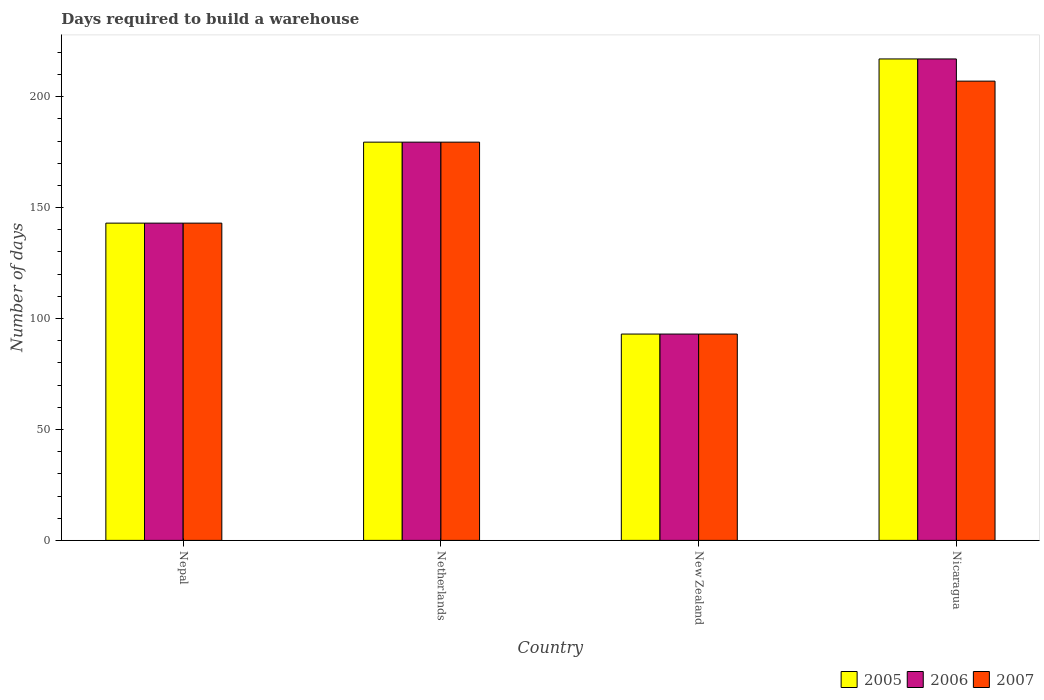Are the number of bars on each tick of the X-axis equal?
Give a very brief answer. Yes. How many bars are there on the 1st tick from the right?
Ensure brevity in your answer.  3. What is the label of the 4th group of bars from the left?
Offer a terse response. Nicaragua. What is the days required to build a warehouse in in 2006 in Netherlands?
Offer a terse response. 179.5. Across all countries, what is the maximum days required to build a warehouse in in 2007?
Offer a very short reply. 207. Across all countries, what is the minimum days required to build a warehouse in in 2005?
Your response must be concise. 93. In which country was the days required to build a warehouse in in 2006 maximum?
Keep it short and to the point. Nicaragua. In which country was the days required to build a warehouse in in 2005 minimum?
Your answer should be very brief. New Zealand. What is the total days required to build a warehouse in in 2007 in the graph?
Ensure brevity in your answer.  622.5. What is the difference between the days required to build a warehouse in in 2005 in Netherlands and that in New Zealand?
Give a very brief answer. 86.5. What is the difference between the days required to build a warehouse in in 2006 in Nicaragua and the days required to build a warehouse in in 2005 in Netherlands?
Your answer should be compact. 37.5. What is the average days required to build a warehouse in in 2007 per country?
Keep it short and to the point. 155.62. What is the ratio of the days required to build a warehouse in in 2007 in Nepal to that in Netherlands?
Ensure brevity in your answer.  0.8. Is the days required to build a warehouse in in 2006 in Netherlands less than that in Nicaragua?
Make the answer very short. Yes. What is the difference between the highest and the second highest days required to build a warehouse in in 2005?
Offer a very short reply. 37.5. What is the difference between the highest and the lowest days required to build a warehouse in in 2005?
Keep it short and to the point. 124. In how many countries, is the days required to build a warehouse in in 2007 greater than the average days required to build a warehouse in in 2007 taken over all countries?
Ensure brevity in your answer.  2. What does the 1st bar from the left in Nepal represents?
Give a very brief answer. 2005. What does the 2nd bar from the right in Nicaragua represents?
Ensure brevity in your answer.  2006. Is it the case that in every country, the sum of the days required to build a warehouse in in 2005 and days required to build a warehouse in in 2007 is greater than the days required to build a warehouse in in 2006?
Keep it short and to the point. Yes. What is the difference between two consecutive major ticks on the Y-axis?
Ensure brevity in your answer.  50. Are the values on the major ticks of Y-axis written in scientific E-notation?
Make the answer very short. No. Does the graph contain any zero values?
Ensure brevity in your answer.  No. How many legend labels are there?
Provide a short and direct response. 3. What is the title of the graph?
Give a very brief answer. Days required to build a warehouse. Does "1997" appear as one of the legend labels in the graph?
Your answer should be compact. No. What is the label or title of the Y-axis?
Your answer should be very brief. Number of days. What is the Number of days of 2005 in Nepal?
Offer a terse response. 143. What is the Number of days in 2006 in Nepal?
Provide a short and direct response. 143. What is the Number of days of 2007 in Nepal?
Ensure brevity in your answer.  143. What is the Number of days of 2005 in Netherlands?
Your answer should be very brief. 179.5. What is the Number of days in 2006 in Netherlands?
Your answer should be compact. 179.5. What is the Number of days in 2007 in Netherlands?
Offer a very short reply. 179.5. What is the Number of days in 2005 in New Zealand?
Keep it short and to the point. 93. What is the Number of days in 2006 in New Zealand?
Provide a short and direct response. 93. What is the Number of days of 2007 in New Zealand?
Offer a very short reply. 93. What is the Number of days in 2005 in Nicaragua?
Provide a succinct answer. 217. What is the Number of days of 2006 in Nicaragua?
Offer a terse response. 217. What is the Number of days of 2007 in Nicaragua?
Your answer should be compact. 207. Across all countries, what is the maximum Number of days of 2005?
Give a very brief answer. 217. Across all countries, what is the maximum Number of days of 2006?
Provide a short and direct response. 217. Across all countries, what is the maximum Number of days in 2007?
Provide a short and direct response. 207. Across all countries, what is the minimum Number of days of 2005?
Make the answer very short. 93. Across all countries, what is the minimum Number of days of 2006?
Offer a very short reply. 93. Across all countries, what is the minimum Number of days of 2007?
Give a very brief answer. 93. What is the total Number of days of 2005 in the graph?
Keep it short and to the point. 632.5. What is the total Number of days in 2006 in the graph?
Your answer should be compact. 632.5. What is the total Number of days in 2007 in the graph?
Offer a very short reply. 622.5. What is the difference between the Number of days of 2005 in Nepal and that in Netherlands?
Provide a short and direct response. -36.5. What is the difference between the Number of days in 2006 in Nepal and that in Netherlands?
Your response must be concise. -36.5. What is the difference between the Number of days in 2007 in Nepal and that in Netherlands?
Your answer should be very brief. -36.5. What is the difference between the Number of days in 2005 in Nepal and that in New Zealand?
Provide a succinct answer. 50. What is the difference between the Number of days in 2005 in Nepal and that in Nicaragua?
Keep it short and to the point. -74. What is the difference between the Number of days of 2006 in Nepal and that in Nicaragua?
Keep it short and to the point. -74. What is the difference between the Number of days in 2007 in Nepal and that in Nicaragua?
Your response must be concise. -64. What is the difference between the Number of days in 2005 in Netherlands and that in New Zealand?
Keep it short and to the point. 86.5. What is the difference between the Number of days of 2006 in Netherlands and that in New Zealand?
Your response must be concise. 86.5. What is the difference between the Number of days in 2007 in Netherlands and that in New Zealand?
Provide a short and direct response. 86.5. What is the difference between the Number of days of 2005 in Netherlands and that in Nicaragua?
Offer a terse response. -37.5. What is the difference between the Number of days in 2006 in Netherlands and that in Nicaragua?
Keep it short and to the point. -37.5. What is the difference between the Number of days in 2007 in Netherlands and that in Nicaragua?
Make the answer very short. -27.5. What is the difference between the Number of days in 2005 in New Zealand and that in Nicaragua?
Your response must be concise. -124. What is the difference between the Number of days in 2006 in New Zealand and that in Nicaragua?
Your response must be concise. -124. What is the difference between the Number of days in 2007 in New Zealand and that in Nicaragua?
Keep it short and to the point. -114. What is the difference between the Number of days of 2005 in Nepal and the Number of days of 2006 in Netherlands?
Make the answer very short. -36.5. What is the difference between the Number of days in 2005 in Nepal and the Number of days in 2007 in Netherlands?
Keep it short and to the point. -36.5. What is the difference between the Number of days in 2006 in Nepal and the Number of days in 2007 in Netherlands?
Provide a short and direct response. -36.5. What is the difference between the Number of days in 2006 in Nepal and the Number of days in 2007 in New Zealand?
Provide a short and direct response. 50. What is the difference between the Number of days in 2005 in Nepal and the Number of days in 2006 in Nicaragua?
Keep it short and to the point. -74. What is the difference between the Number of days of 2005 in Nepal and the Number of days of 2007 in Nicaragua?
Give a very brief answer. -64. What is the difference between the Number of days of 2006 in Nepal and the Number of days of 2007 in Nicaragua?
Your answer should be compact. -64. What is the difference between the Number of days in 2005 in Netherlands and the Number of days in 2006 in New Zealand?
Give a very brief answer. 86.5. What is the difference between the Number of days of 2005 in Netherlands and the Number of days of 2007 in New Zealand?
Keep it short and to the point. 86.5. What is the difference between the Number of days in 2006 in Netherlands and the Number of days in 2007 in New Zealand?
Make the answer very short. 86.5. What is the difference between the Number of days of 2005 in Netherlands and the Number of days of 2006 in Nicaragua?
Make the answer very short. -37.5. What is the difference between the Number of days in 2005 in Netherlands and the Number of days in 2007 in Nicaragua?
Offer a very short reply. -27.5. What is the difference between the Number of days in 2006 in Netherlands and the Number of days in 2007 in Nicaragua?
Offer a terse response. -27.5. What is the difference between the Number of days of 2005 in New Zealand and the Number of days of 2006 in Nicaragua?
Ensure brevity in your answer.  -124. What is the difference between the Number of days in 2005 in New Zealand and the Number of days in 2007 in Nicaragua?
Make the answer very short. -114. What is the difference between the Number of days of 2006 in New Zealand and the Number of days of 2007 in Nicaragua?
Provide a short and direct response. -114. What is the average Number of days of 2005 per country?
Give a very brief answer. 158.12. What is the average Number of days in 2006 per country?
Provide a short and direct response. 158.12. What is the average Number of days in 2007 per country?
Give a very brief answer. 155.62. What is the difference between the Number of days of 2005 and Number of days of 2007 in Nepal?
Offer a terse response. 0. What is the difference between the Number of days in 2005 and Number of days in 2006 in Netherlands?
Keep it short and to the point. 0. What is the difference between the Number of days in 2005 and Number of days in 2007 in Netherlands?
Keep it short and to the point. 0. What is the difference between the Number of days of 2005 and Number of days of 2006 in Nicaragua?
Provide a succinct answer. 0. What is the difference between the Number of days in 2006 and Number of days in 2007 in Nicaragua?
Provide a short and direct response. 10. What is the ratio of the Number of days of 2005 in Nepal to that in Netherlands?
Offer a very short reply. 0.8. What is the ratio of the Number of days of 2006 in Nepal to that in Netherlands?
Your answer should be compact. 0.8. What is the ratio of the Number of days of 2007 in Nepal to that in Netherlands?
Ensure brevity in your answer.  0.8. What is the ratio of the Number of days of 2005 in Nepal to that in New Zealand?
Give a very brief answer. 1.54. What is the ratio of the Number of days of 2006 in Nepal to that in New Zealand?
Offer a very short reply. 1.54. What is the ratio of the Number of days in 2007 in Nepal to that in New Zealand?
Provide a short and direct response. 1.54. What is the ratio of the Number of days in 2005 in Nepal to that in Nicaragua?
Offer a terse response. 0.66. What is the ratio of the Number of days in 2006 in Nepal to that in Nicaragua?
Your answer should be compact. 0.66. What is the ratio of the Number of days in 2007 in Nepal to that in Nicaragua?
Provide a succinct answer. 0.69. What is the ratio of the Number of days of 2005 in Netherlands to that in New Zealand?
Make the answer very short. 1.93. What is the ratio of the Number of days of 2006 in Netherlands to that in New Zealand?
Keep it short and to the point. 1.93. What is the ratio of the Number of days in 2007 in Netherlands to that in New Zealand?
Keep it short and to the point. 1.93. What is the ratio of the Number of days in 2005 in Netherlands to that in Nicaragua?
Your answer should be compact. 0.83. What is the ratio of the Number of days in 2006 in Netherlands to that in Nicaragua?
Your answer should be very brief. 0.83. What is the ratio of the Number of days of 2007 in Netherlands to that in Nicaragua?
Ensure brevity in your answer.  0.87. What is the ratio of the Number of days in 2005 in New Zealand to that in Nicaragua?
Your answer should be compact. 0.43. What is the ratio of the Number of days of 2006 in New Zealand to that in Nicaragua?
Provide a short and direct response. 0.43. What is the ratio of the Number of days in 2007 in New Zealand to that in Nicaragua?
Ensure brevity in your answer.  0.45. What is the difference between the highest and the second highest Number of days of 2005?
Your answer should be very brief. 37.5. What is the difference between the highest and the second highest Number of days of 2006?
Offer a very short reply. 37.5. What is the difference between the highest and the lowest Number of days in 2005?
Give a very brief answer. 124. What is the difference between the highest and the lowest Number of days in 2006?
Your answer should be compact. 124. What is the difference between the highest and the lowest Number of days in 2007?
Your answer should be very brief. 114. 